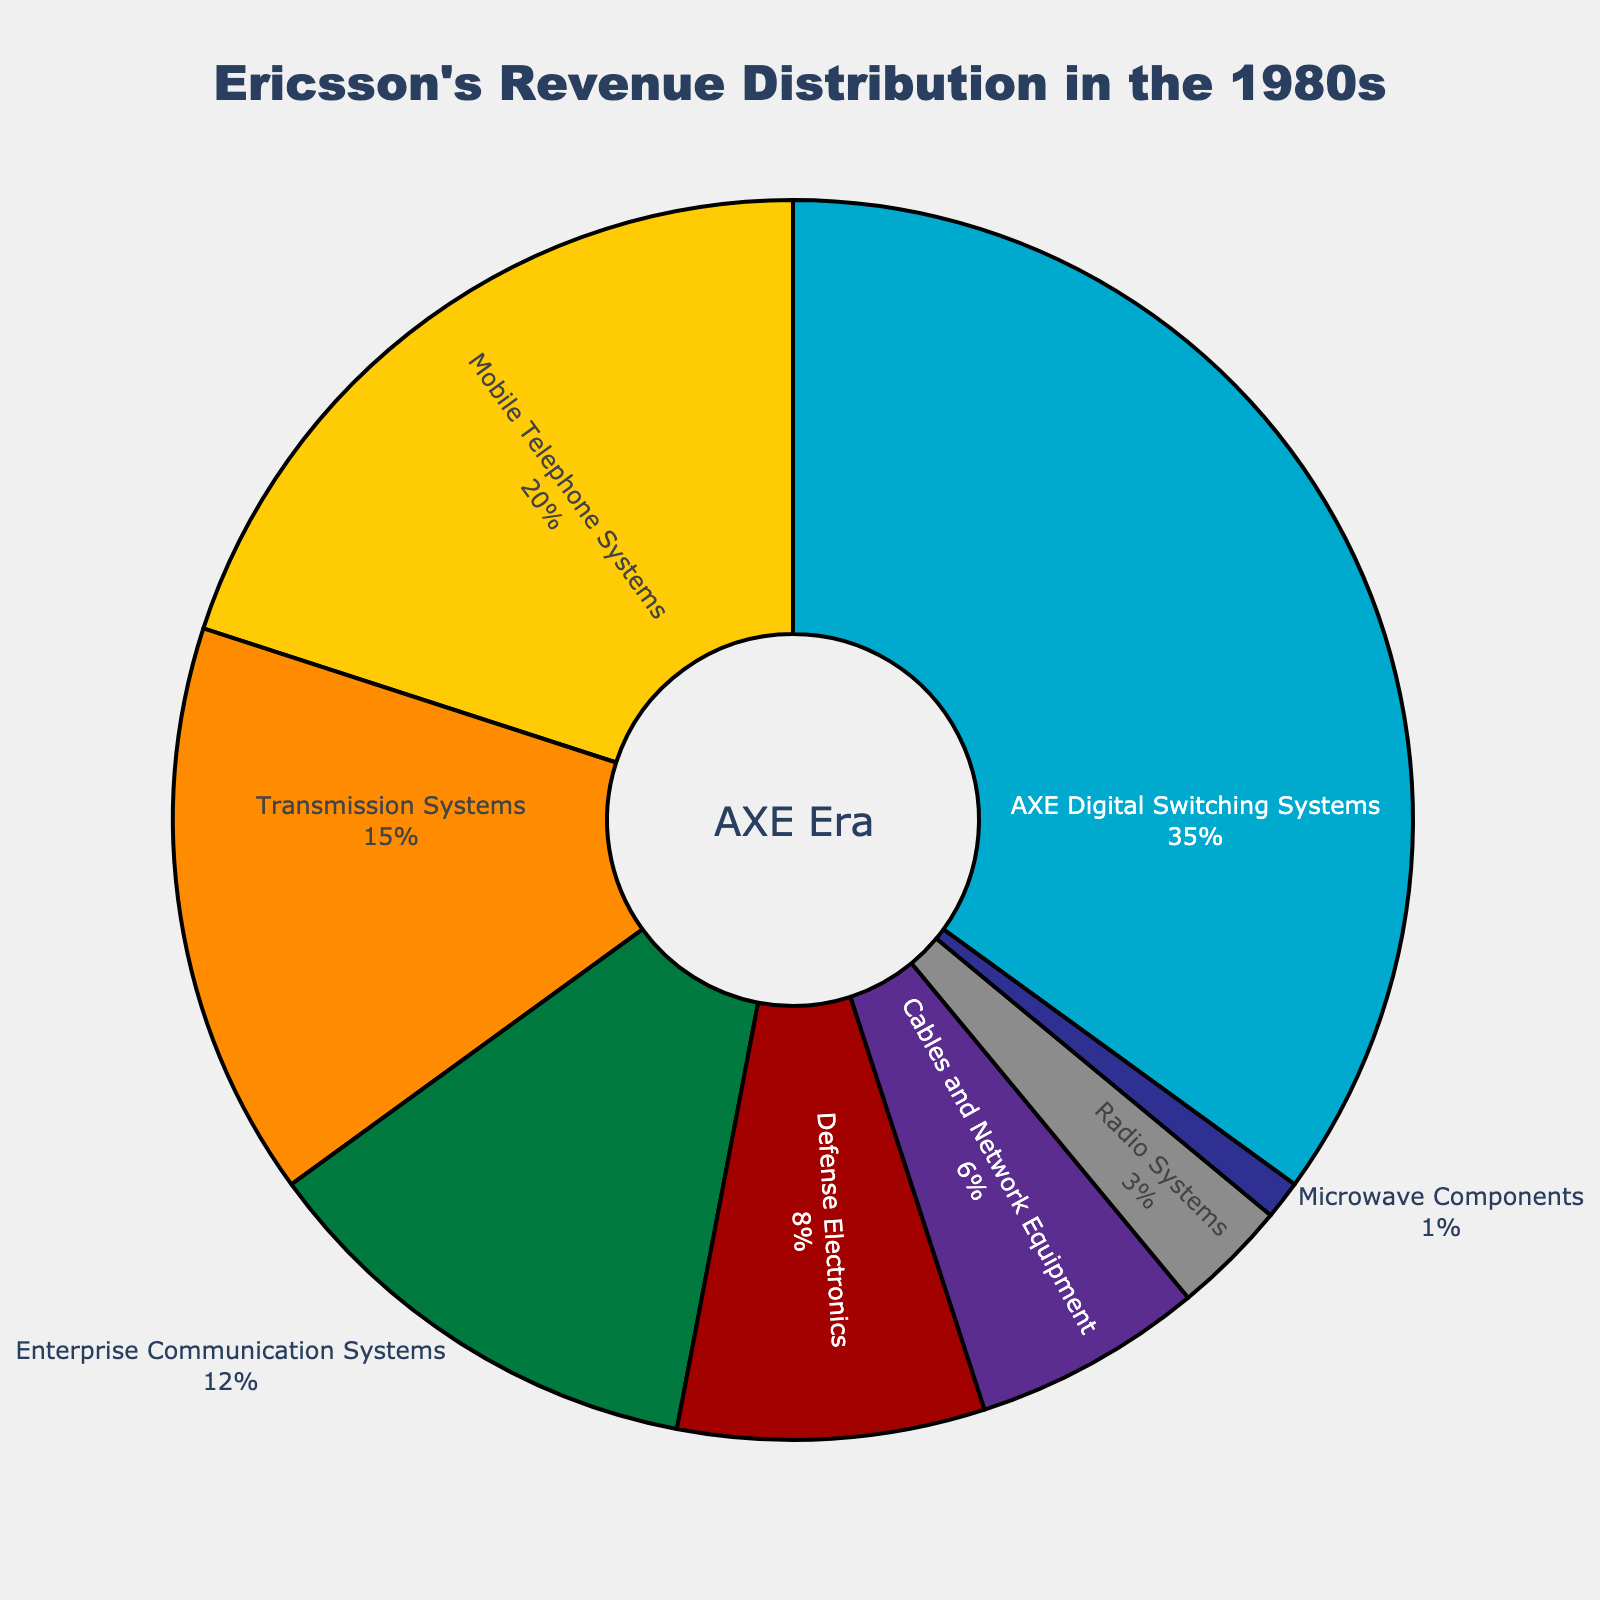What product line contributed the largest percentage to Ericsson's revenue in the 1980s? To find the largest percentage contribution, one should identify the product line with the highest revenue percentage slice in the pie chart. From the visual data, AXE Digital Switching Systems has the largest share.
Answer: AXE Digital Switching Systems Which two product lines together account for 50% of the revenue? Adding up the percentages of different product lines, we see that AXE Digital Switching Systems contributes 35% and Mobile Telephone Systems contributes 20%. Combined, this is 35% + 20% = 55%. We need 50%, so we try AXE Digital Switching Systems (35%) plus Enterprise Communication Systems (12%), giving 35% + 12% = 47%. This is not 50%. Continuing this way, we find that AXE Digital Switching Systems (35%) plus Transmission Systems (15%) sum to 50%.
Answer: AXE Digital Switching Systems and Transmission Systems Which product line contributes approximately the same percentage as Defense Electronics and Cables and Network Equipment combined? Adding the contributions of Defense Electronics (8%) and Cables and Network Equipment (6%), we get 8% + 6% = 14%. From the pie chart, Enterprise Communication Systems contributes 12%, which is close but not exact. So, we see Transmission Systems at 15%, quite close to 14%.
Answer: Transmission Systems What is the combined percentage contribution of the bottom three product lines to Ericsson's revenue? The bottom three product lines are Radio Systems (3%), Microwave Components (1%), and Cables and Network Equipment (6%). Adding these gives 3% + 1% + 6% = 10%.
Answer: 10% Which product line has a larger revenue percentage, Enterprise Communication Systems or Defense Electronics, and by how much? To determine which product line contributes more and by what amount, compare the percentages: Enterprise Communication Systems (12%) and Defense Electronics (8%). The difference is 12% - 8% = 4%.
Answer: Enterprise Communication Systems by 4% Compare the revenue percentage contribution of Mobile Telephone Systems with Defense Electronics. What is the ratio of their contributions? Mobile Telephone Systems contribute 20% and Defense Electronics contribute 8%. The ratio is calculated as 20% / 8% which simplifies to 2.5.
Answer: 2.5 How much more revenue percentage did AXE Digital Switching Systems generate compared to Radio Systems? The revenue percentage for AXE Digital Switching Systems is 35%, and for Radio Systems, it is 3%. The difference is 35% - 3% = 32%.
Answer: 32% Which color represents Cables and Network Equipment in the pie chart? By reviewing the described colors, Cables and Network Equipment is marked by a specific color segment. Since Cables and Network Equipment is the 6th item in the color list, it is marked by the color '#5C2D91'. Based on the natural label for colors, it likely corresponds to purple in the pie chart.
Answer: Purple 